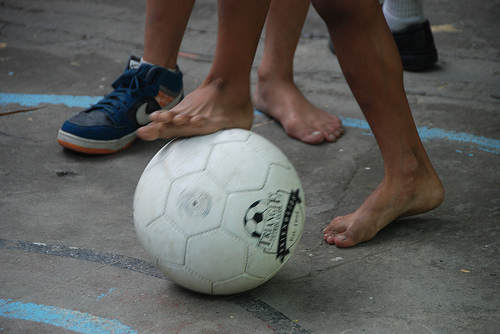<image>
Is the ball under the kid? Yes. The ball is positioned underneath the kid, with the kid above it in the vertical space. 